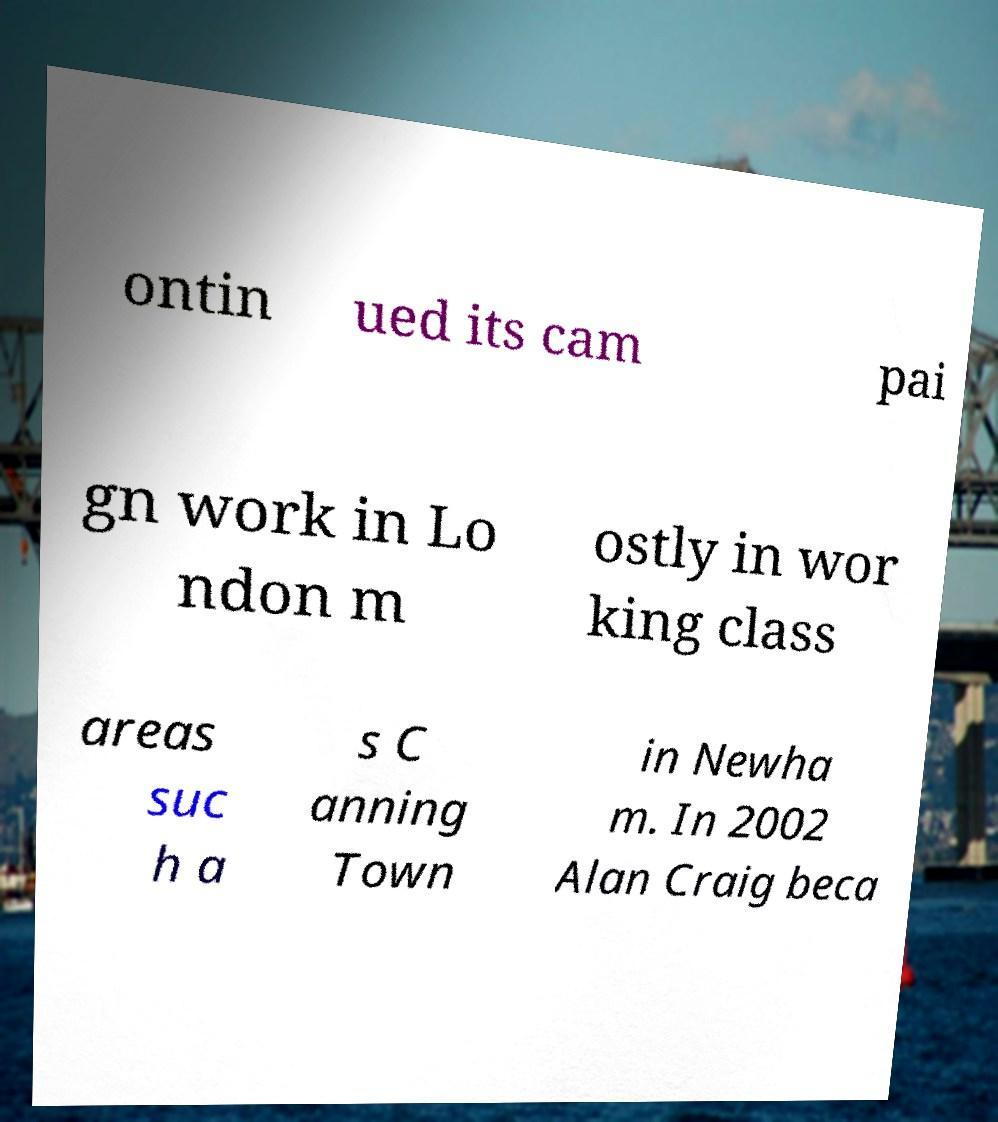Can you accurately transcribe the text from the provided image for me? ontin ued its cam pai gn work in Lo ndon m ostly in wor king class areas suc h a s C anning Town in Newha m. In 2002 Alan Craig beca 